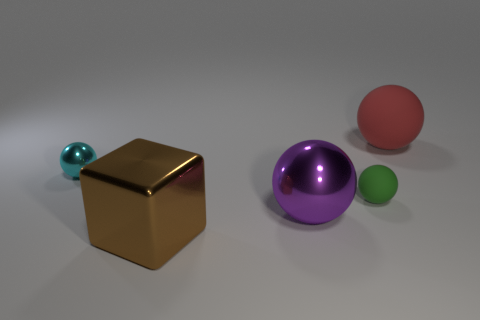There is a tiny cyan thing that is the same shape as the big red thing; what is it made of?
Keep it short and to the point. Metal. The shiny thing that is in front of the cyan metallic object and behind the brown metallic block is what color?
Your response must be concise. Purple. Are there more large gray things than big balls?
Give a very brief answer. No. There is a big thing that is right of the purple sphere; is its shape the same as the cyan shiny object?
Your response must be concise. Yes. How many metal things are brown objects or large green blocks?
Keep it short and to the point. 1. Are there any large brown objects that have the same material as the small green ball?
Give a very brief answer. No. What is the material of the brown object?
Ensure brevity in your answer.  Metal. There is a rubber object behind the ball to the left of the big object in front of the big purple shiny sphere; what shape is it?
Offer a terse response. Sphere. Is the number of small green matte objects that are right of the large red matte ball greater than the number of tiny matte objects?
Provide a succinct answer. No. Is the shape of the cyan object the same as the big thing that is left of the purple ball?
Keep it short and to the point. No. 